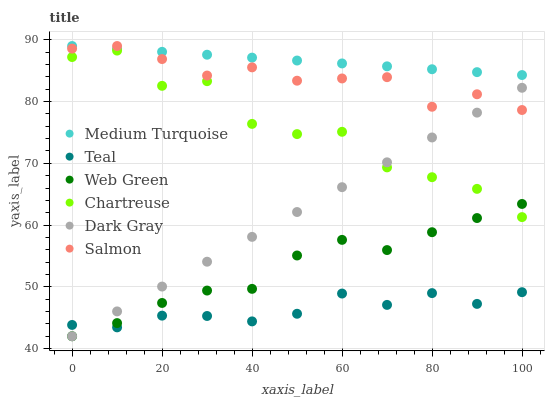Does Teal have the minimum area under the curve?
Answer yes or no. Yes. Does Medium Turquoise have the maximum area under the curve?
Answer yes or no. Yes. Does Salmon have the minimum area under the curve?
Answer yes or no. No. Does Salmon have the maximum area under the curve?
Answer yes or no. No. Is Medium Turquoise the smoothest?
Answer yes or no. Yes. Is Chartreuse the roughest?
Answer yes or no. Yes. Is Salmon the smoothest?
Answer yes or no. No. Is Salmon the roughest?
Answer yes or no. No. Does Web Green have the lowest value?
Answer yes or no. Yes. Does Salmon have the lowest value?
Answer yes or no. No. Does Salmon have the highest value?
Answer yes or no. Yes. Does Web Green have the highest value?
Answer yes or no. No. Is Chartreuse less than Salmon?
Answer yes or no. Yes. Is Chartreuse greater than Teal?
Answer yes or no. Yes. Does Teal intersect Web Green?
Answer yes or no. Yes. Is Teal less than Web Green?
Answer yes or no. No. Is Teal greater than Web Green?
Answer yes or no. No. Does Chartreuse intersect Salmon?
Answer yes or no. No. 